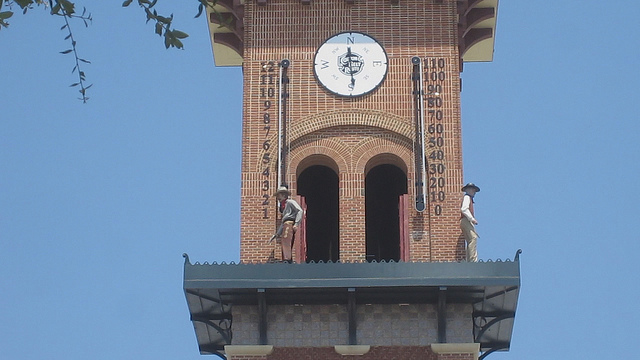Is there any significance to the number layout on the clock face? The clock face follows a standard layout with numbers one through twelve, which is typical for analog clocks. This layout originates from the base-12 counting system and has been standardized over centuries for ease of reading and universal understanding. The specific fonts and style of the numbers can sometimes offer insight into the period when the clock was made or any cultural significance, but in this case, it is a clear, legible typeface intended for practical visibility. 